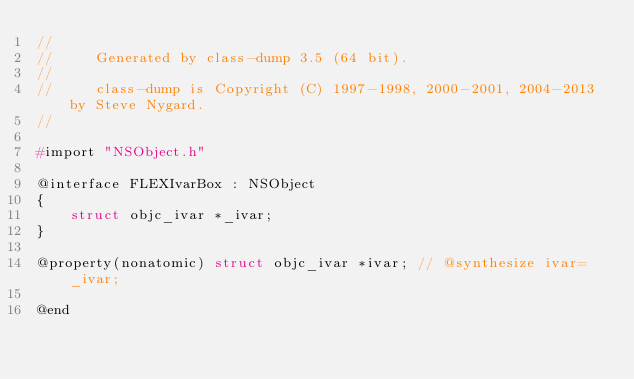<code> <loc_0><loc_0><loc_500><loc_500><_C_>//
//     Generated by class-dump 3.5 (64 bit).
//
//     class-dump is Copyright (C) 1997-1998, 2000-2001, 2004-2013 by Steve Nygard.
//

#import "NSObject.h"

@interface FLEXIvarBox : NSObject
{
    struct objc_ivar *_ivar;
}

@property(nonatomic) struct objc_ivar *ivar; // @synthesize ivar=_ivar;

@end

</code> 